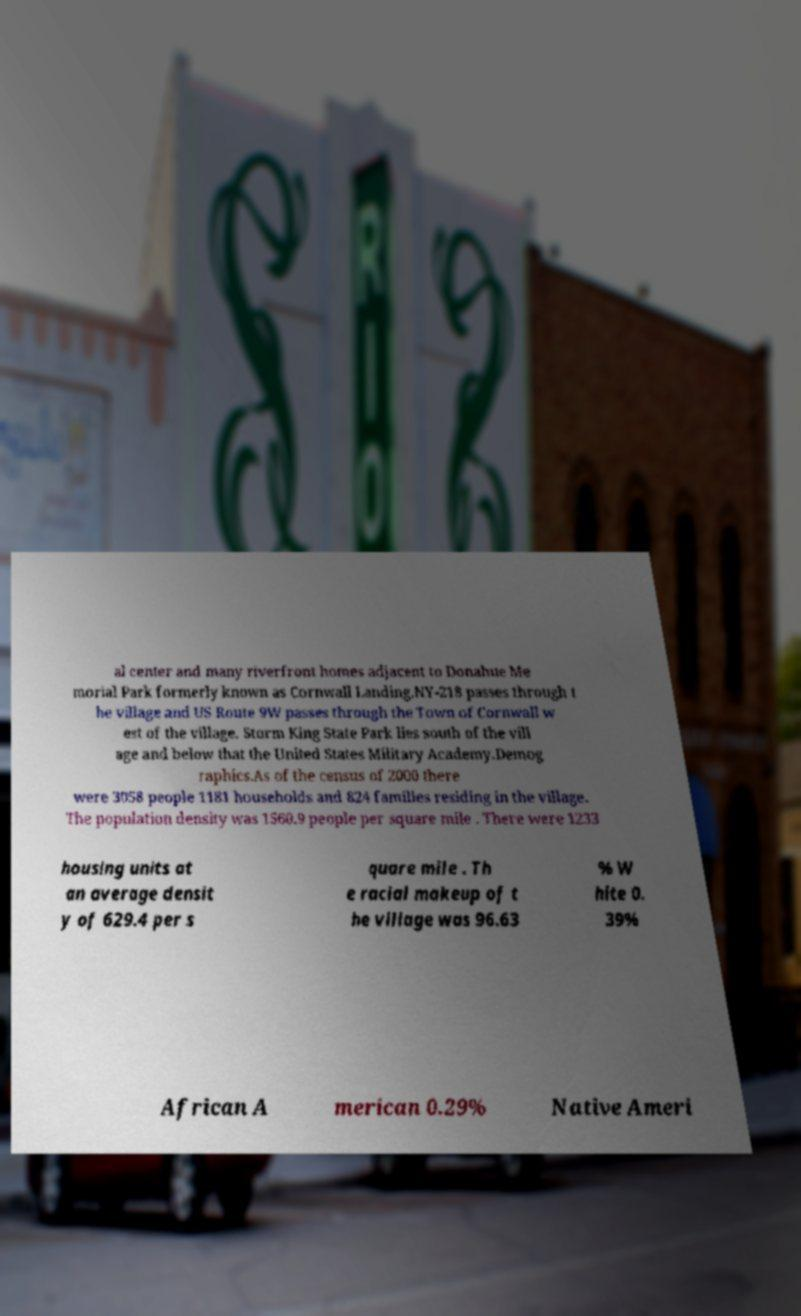There's text embedded in this image that I need extracted. Can you transcribe it verbatim? al center and many riverfront homes adjacent to Donahue Me morial Park formerly known as Cornwall Landing.NY-218 passes through t he village and US Route 9W passes through the Town of Cornwall w est of the village. Storm King State Park lies south of the vill age and below that the United States Military Academy.Demog raphics.As of the census of 2000 there were 3058 people 1181 households and 824 families residing in the village. The population density was 1560.9 people per square mile . There were 1233 housing units at an average densit y of 629.4 per s quare mile . Th e racial makeup of t he village was 96.63 % W hite 0. 39% African A merican 0.29% Native Ameri 